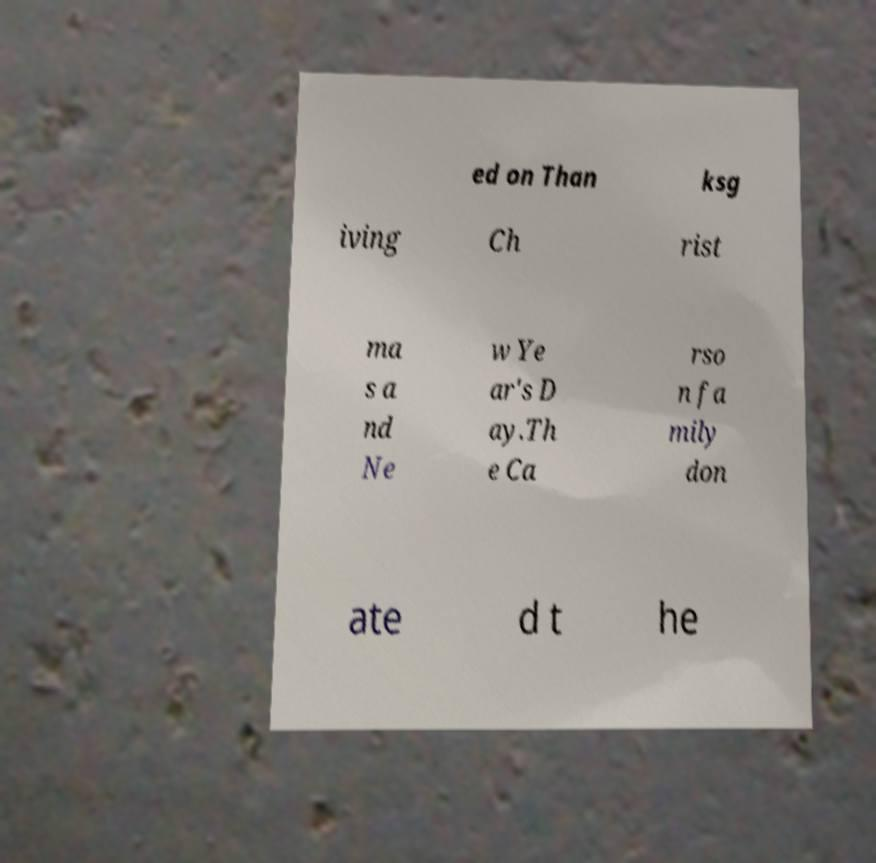Can you accurately transcribe the text from the provided image for me? ed on Than ksg iving Ch rist ma s a nd Ne w Ye ar's D ay.Th e Ca rso n fa mily don ate d t he 